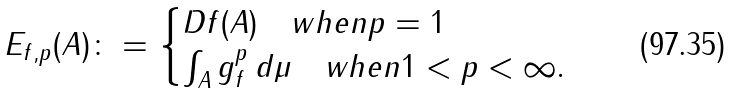Convert formula to latex. <formula><loc_0><loc_0><loc_500><loc_500>E _ { f , p } ( A ) \colon = \begin{cases} \| D f \| ( A ) \quad w h e n p = 1 \\ \int _ { A } g _ { f } ^ { p } \, d \mu \quad w h e n 1 < p < \infty . \end{cases}</formula> 